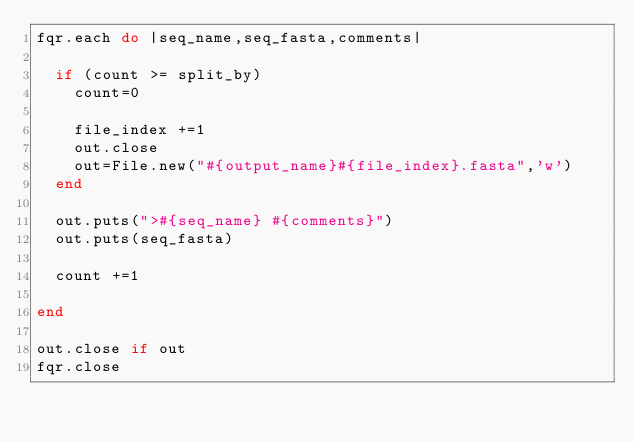<code> <loc_0><loc_0><loc_500><loc_500><_Ruby_>fqr.each do |seq_name,seq_fasta,comments|

  if (count >= split_by)
    count=0

    file_index +=1
    out.close
    out=File.new("#{output_name}#{file_index}.fasta",'w')
  end

  out.puts(">#{seq_name} #{comments}")
  out.puts(seq_fasta)

  count +=1

end

out.close if out
fqr.close</code> 